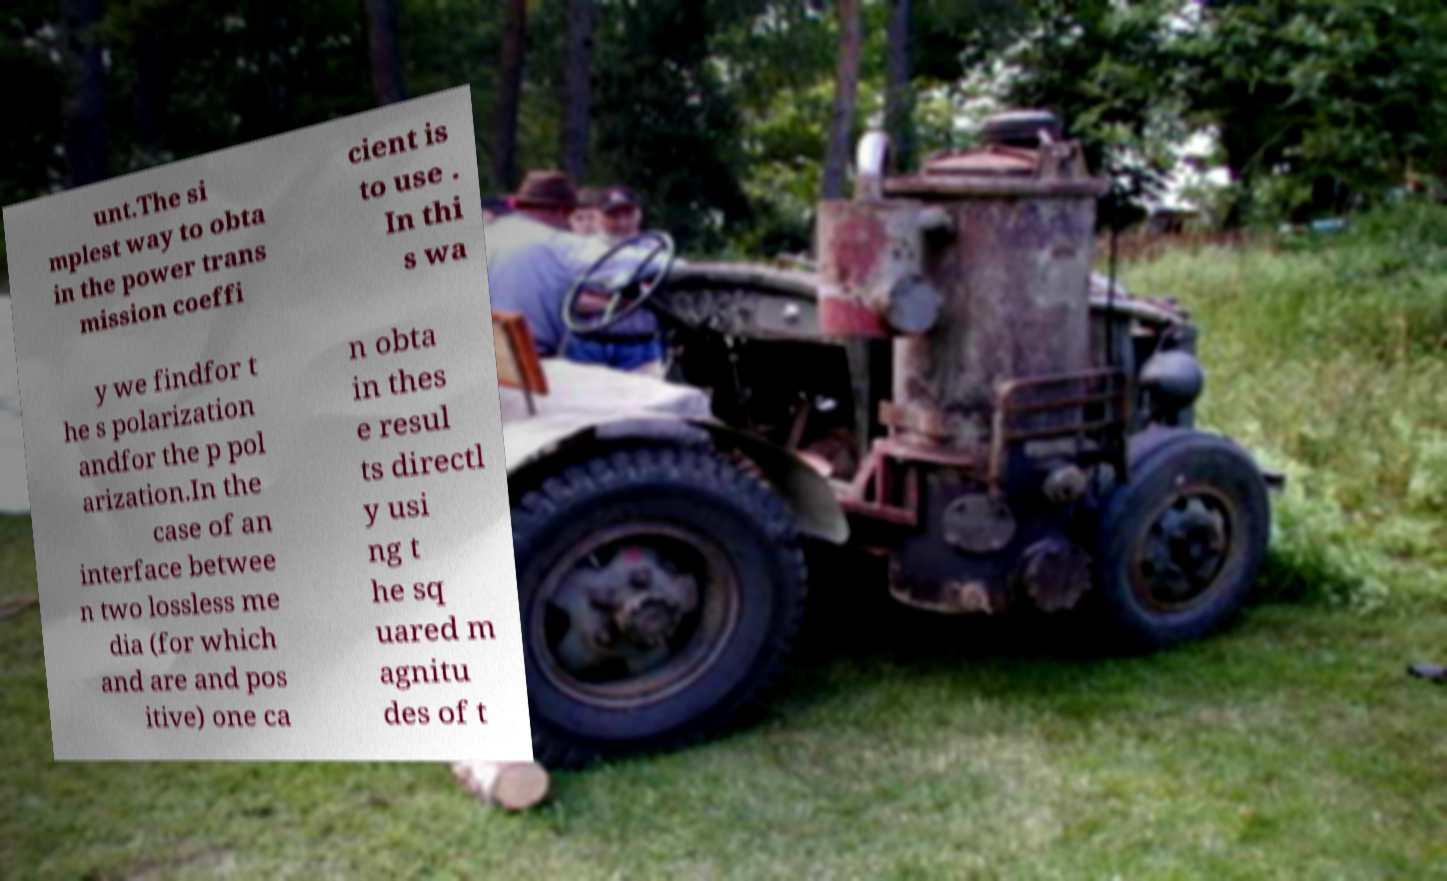What messages or text are displayed in this image? I need them in a readable, typed format. unt.The si mplest way to obta in the power trans mission coeffi cient is to use . In thi s wa y we findfor t he s polarization andfor the p pol arization.In the case of an interface betwee n two lossless me dia (for which and are and pos itive) one ca n obta in thes e resul ts directl y usi ng t he sq uared m agnitu des of t 